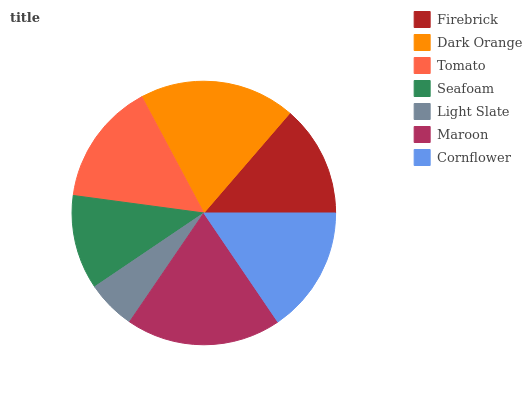Is Light Slate the minimum?
Answer yes or no. Yes. Is Dark Orange the maximum?
Answer yes or no. Yes. Is Tomato the minimum?
Answer yes or no. No. Is Tomato the maximum?
Answer yes or no. No. Is Dark Orange greater than Tomato?
Answer yes or no. Yes. Is Tomato less than Dark Orange?
Answer yes or no. Yes. Is Tomato greater than Dark Orange?
Answer yes or no. No. Is Dark Orange less than Tomato?
Answer yes or no. No. Is Tomato the high median?
Answer yes or no. Yes. Is Tomato the low median?
Answer yes or no. Yes. Is Seafoam the high median?
Answer yes or no. No. Is Cornflower the low median?
Answer yes or no. No. 